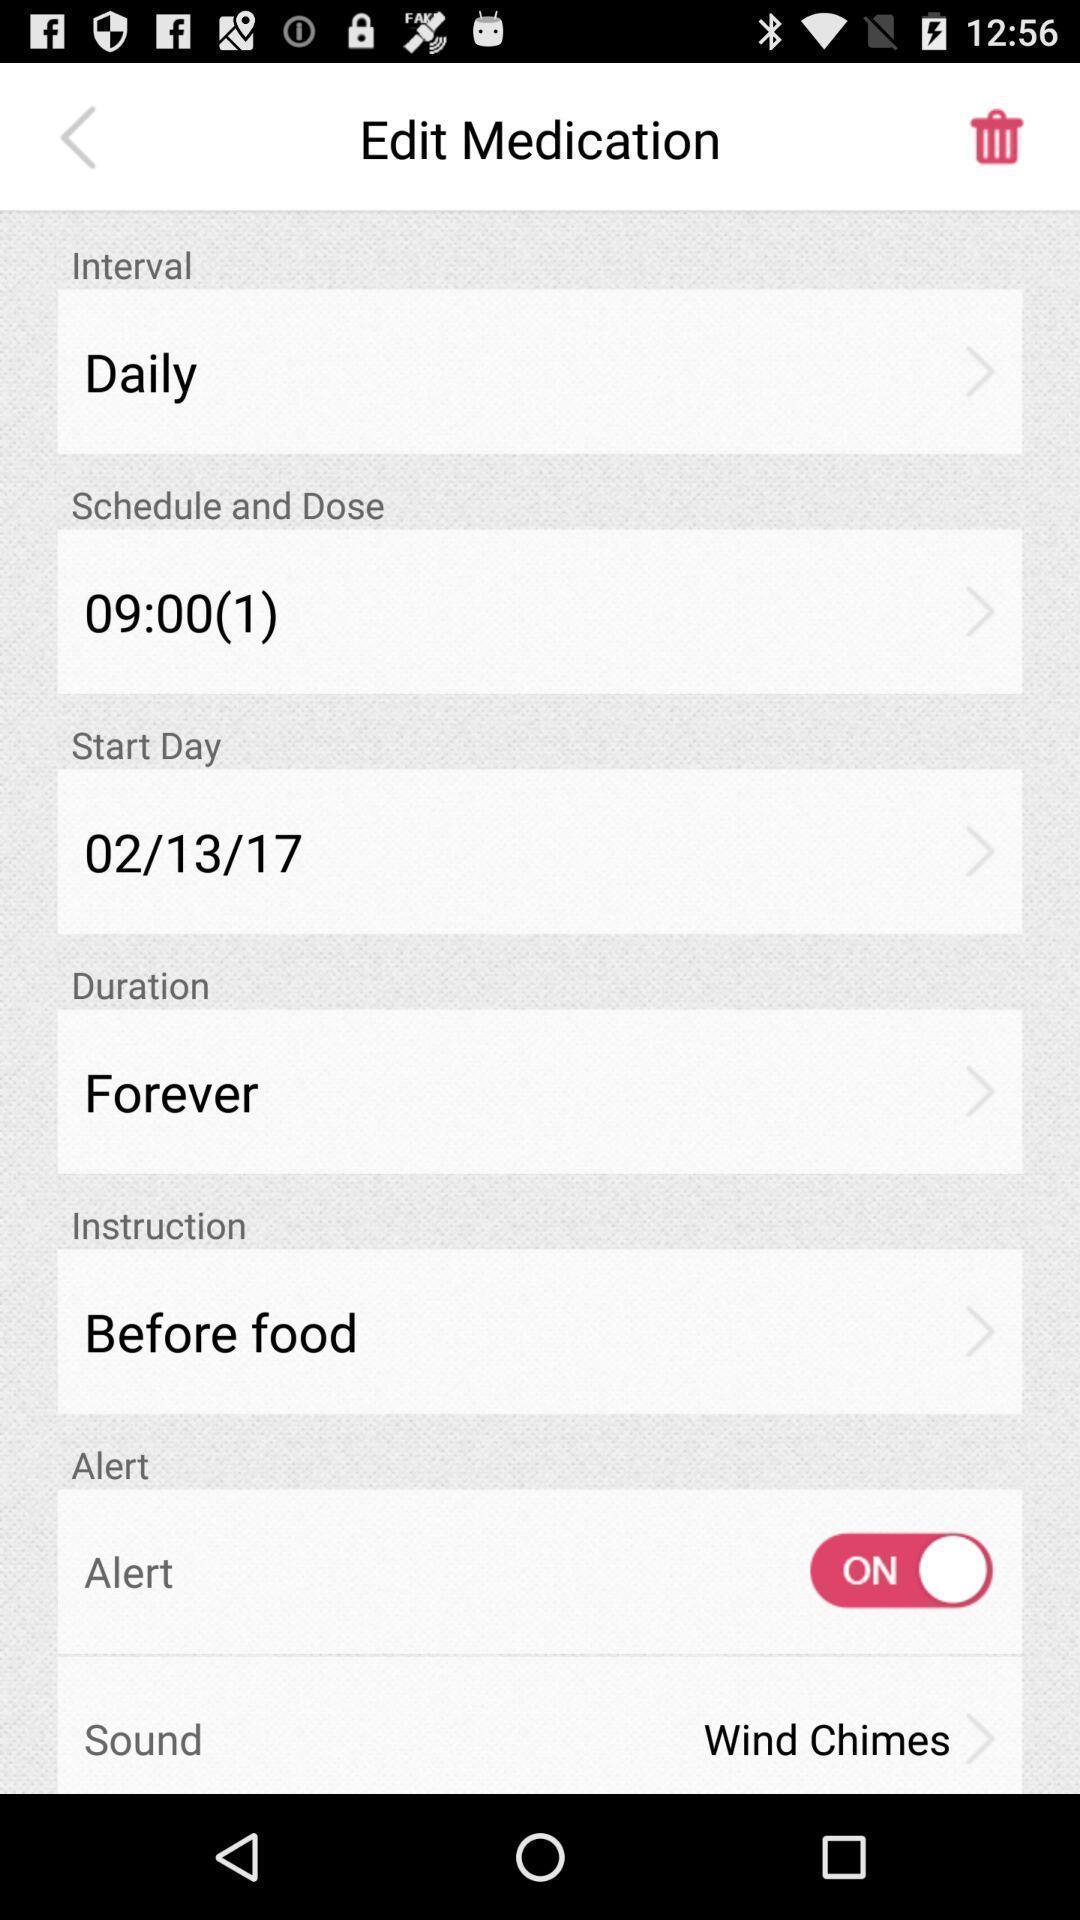Give me a narrative description of this picture. Various options presented in an medication app. 